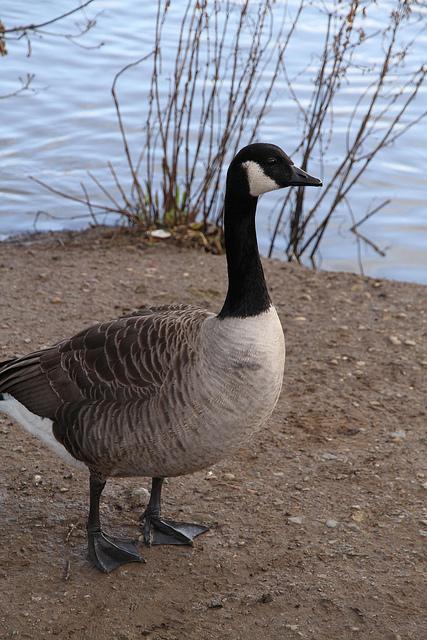Where is the bird?
Keep it brief. On land. Is the animal going to jump into the water?
Concise answer only. No. Where is the duck?
Give a very brief answer. Beach. How many adult geese?
Concise answer only. 1. What color are the duck's feet?
Short answer required. Black. How many legs is the bird perched on?
Write a very short answer. 2. What type of animal is this?
Keep it brief. Goose. Can you see the ducks shadow?
Concise answer only. No. 